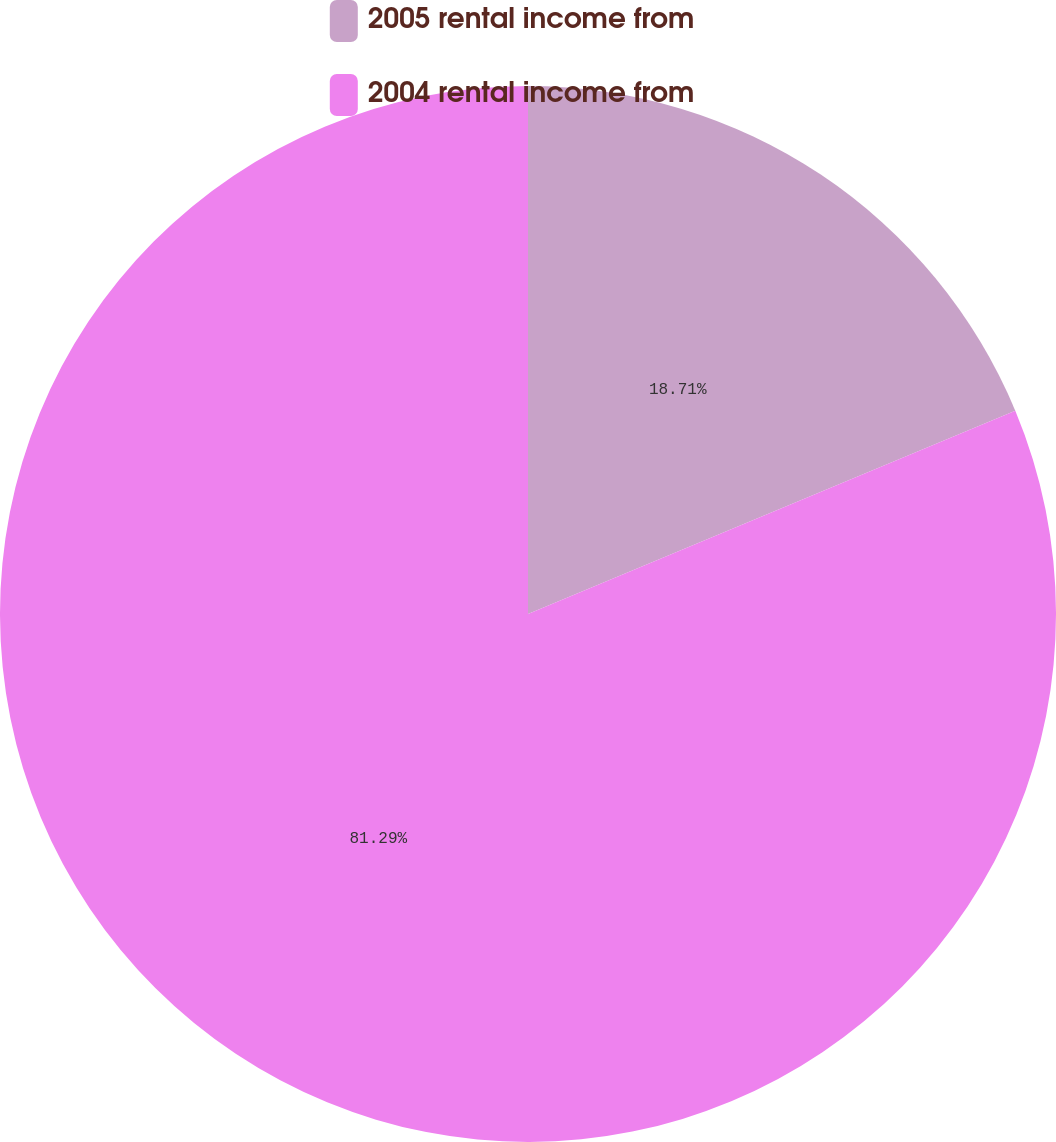Convert chart. <chart><loc_0><loc_0><loc_500><loc_500><pie_chart><fcel>2005 rental income from<fcel>2004 rental income from<nl><fcel>18.71%<fcel>81.29%<nl></chart> 